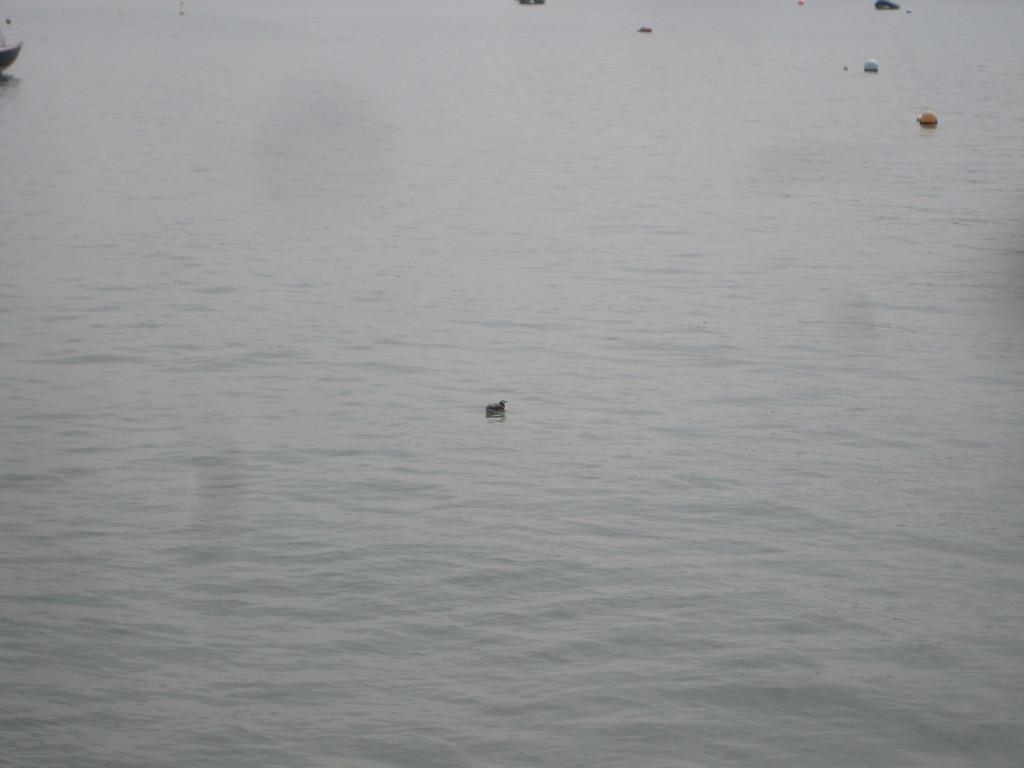Please provide a concise description of this image. In the picture I can see water on which I can see some objects. 